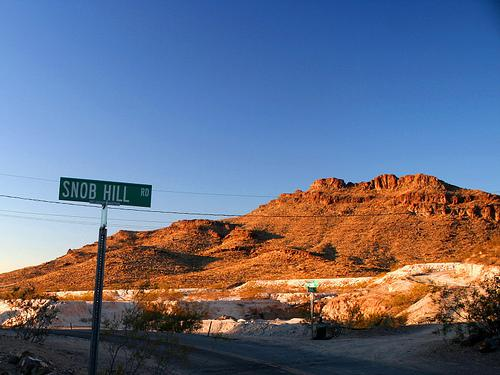Question: where was the picture taken?
Choices:
A. On the bus.
B. On the sidewalk.
C. On the street.
D. On the beach.
Answer with the letter. Answer: C Question: what does the sign say?
Choices:
A. Children crossing.
B. Bumps ahead.
C. Intersection.
D. Snob Hill Rd.
Answer with the letter. Answer: D Question: who is in the picture?
Choices:
A. Someone.
B. Nobody.
C. Anybody.
D. Somebody.
Answer with the letter. Answer: B Question: what color is the mountain?
Choices:
A. White.
B. Black.
C. Brown.
D. Gray.
Answer with the letter. Answer: C Question: how many clouds are in the sky?
Choices:
A. One.
B. Two.
C. None.
D. Three.
Answer with the letter. Answer: C Question: what color is the sky?
Choices:
A. Gray.
B. Black.
C. Blue.
D. Red.
Answer with the letter. Answer: C 